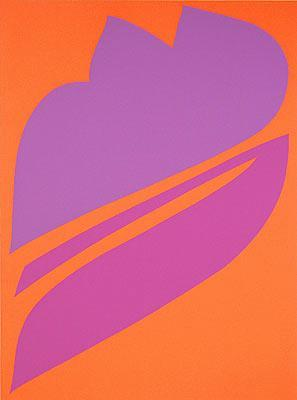In a fantastical world, what could this piece represent? In a fantastical world, this piece could represent a magical leaf from a mythical tree that blooms once every thousand years. The bright orange background could be the sky during a celestial event, like a double sunset, casting an ethereal glow over the land. The large purple form might be the sacred leaf that holds the power to control time and space, revered by the inhabitants of this mystical realm. They believe that the leaf's unique shape symbolizes the interconnectedness of all life and the harmony of the universe. 